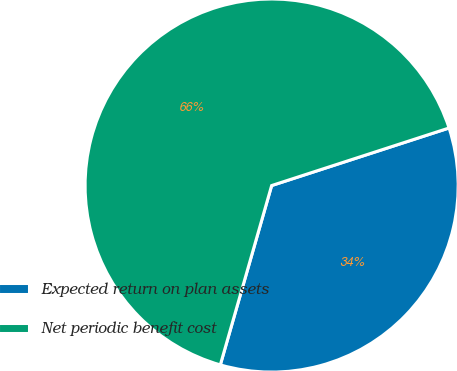Convert chart. <chart><loc_0><loc_0><loc_500><loc_500><pie_chart><fcel>Expected return on plan assets<fcel>Net periodic benefit cost<nl><fcel>34.43%<fcel>65.57%<nl></chart> 